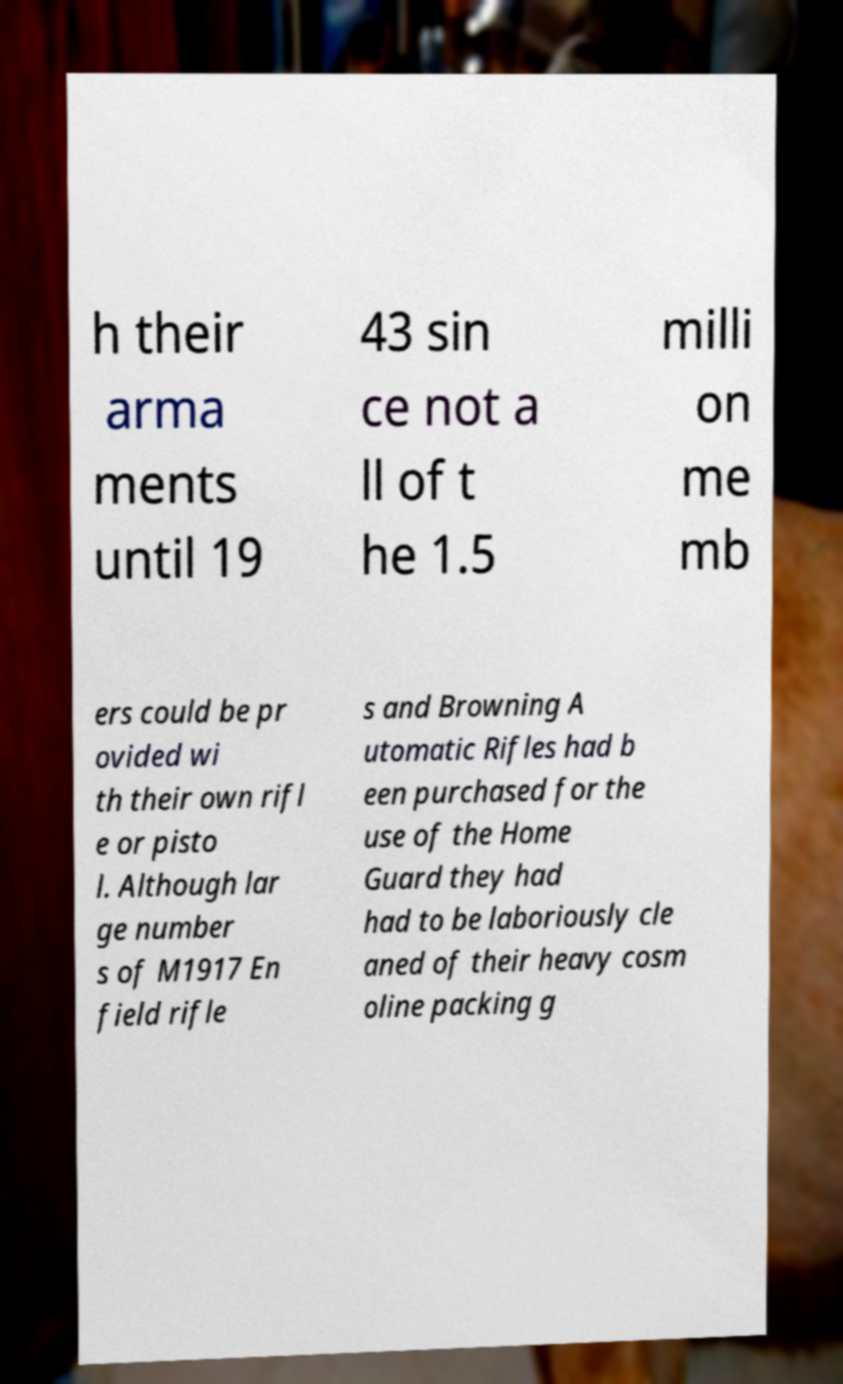For documentation purposes, I need the text within this image transcribed. Could you provide that? h their arma ments until 19 43 sin ce not a ll of t he 1.5 milli on me mb ers could be pr ovided wi th their own rifl e or pisto l. Although lar ge number s of M1917 En field rifle s and Browning A utomatic Rifles had b een purchased for the use of the Home Guard they had had to be laboriously cle aned of their heavy cosm oline packing g 